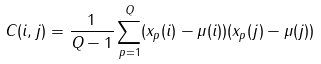<formula> <loc_0><loc_0><loc_500><loc_500>C ( i , j ) = \frac { 1 } { Q - 1 } \sum _ { p = 1 } ^ { Q } ( x _ { p } ( i ) - \mu ( i ) ) ( x _ { p } ( j ) - \mu ( j ) )</formula> 